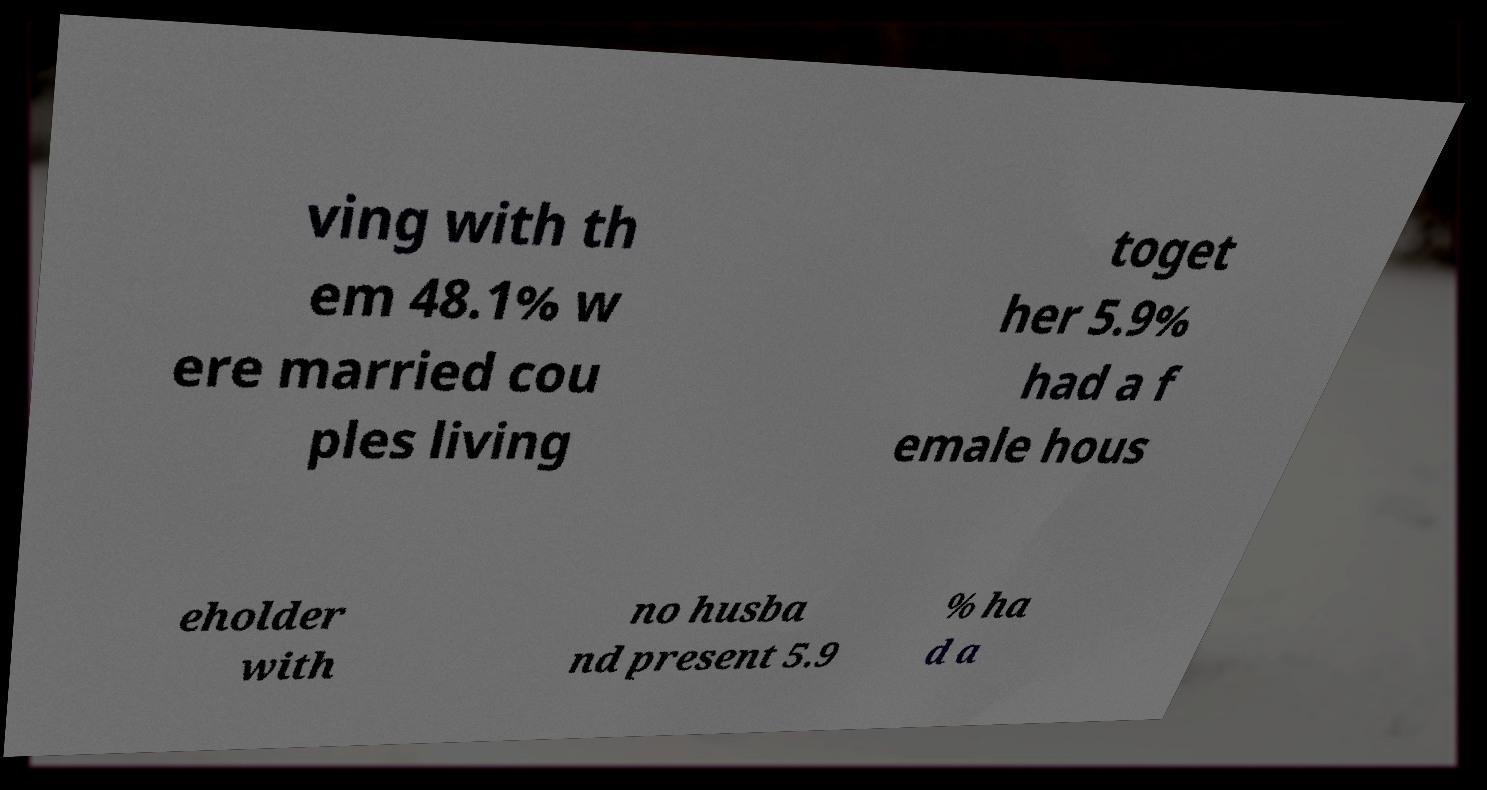There's text embedded in this image that I need extracted. Can you transcribe it verbatim? ving with th em 48.1% w ere married cou ples living toget her 5.9% had a f emale hous eholder with no husba nd present 5.9 % ha d a 